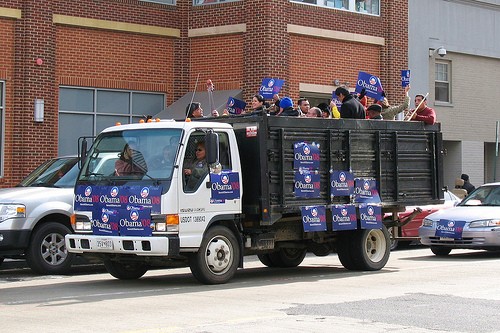Describe the setting shown in the image. The image shows a street scene with a truck heavily adorned with Obama '08 campaign signs. The truck has an open cargo area where people are seated and holding additional Obama signs. It is parked in front of a red brick building and alongside other vehicles. What do you think is the main purpose of the truck in this image? The main purpose of the truck in this image is likely to serve as a moving billboard for Barack Obama's presidential campaign, showing support and spreading awareness during a political rally or event. Can you imagine an exciting backstory for this event? Imagine this: The truck is part of a grand parade in honor of Barack Obama's candidacy, with thousands of supporters lining the streets. The people on the truck are volunteers who have devoted their time to canvassing neighborhoods and spreading enthusiasm about the campaign. As the truck slowly rolls down the street, chants and cheers fill the air. Nearby shops and homes display similar signs, and children wave small flags. This parade is the culmination of weeks of planning, representing a community united in its support for change and hope for the future. The excitement is palpable, with everyone eager for a new direction in leadership.  If you were to write a headline for a news article about this moment, what would it be? "Enthusiastic Supporters Rally Behind Obama in Vibrant Street Parade" 